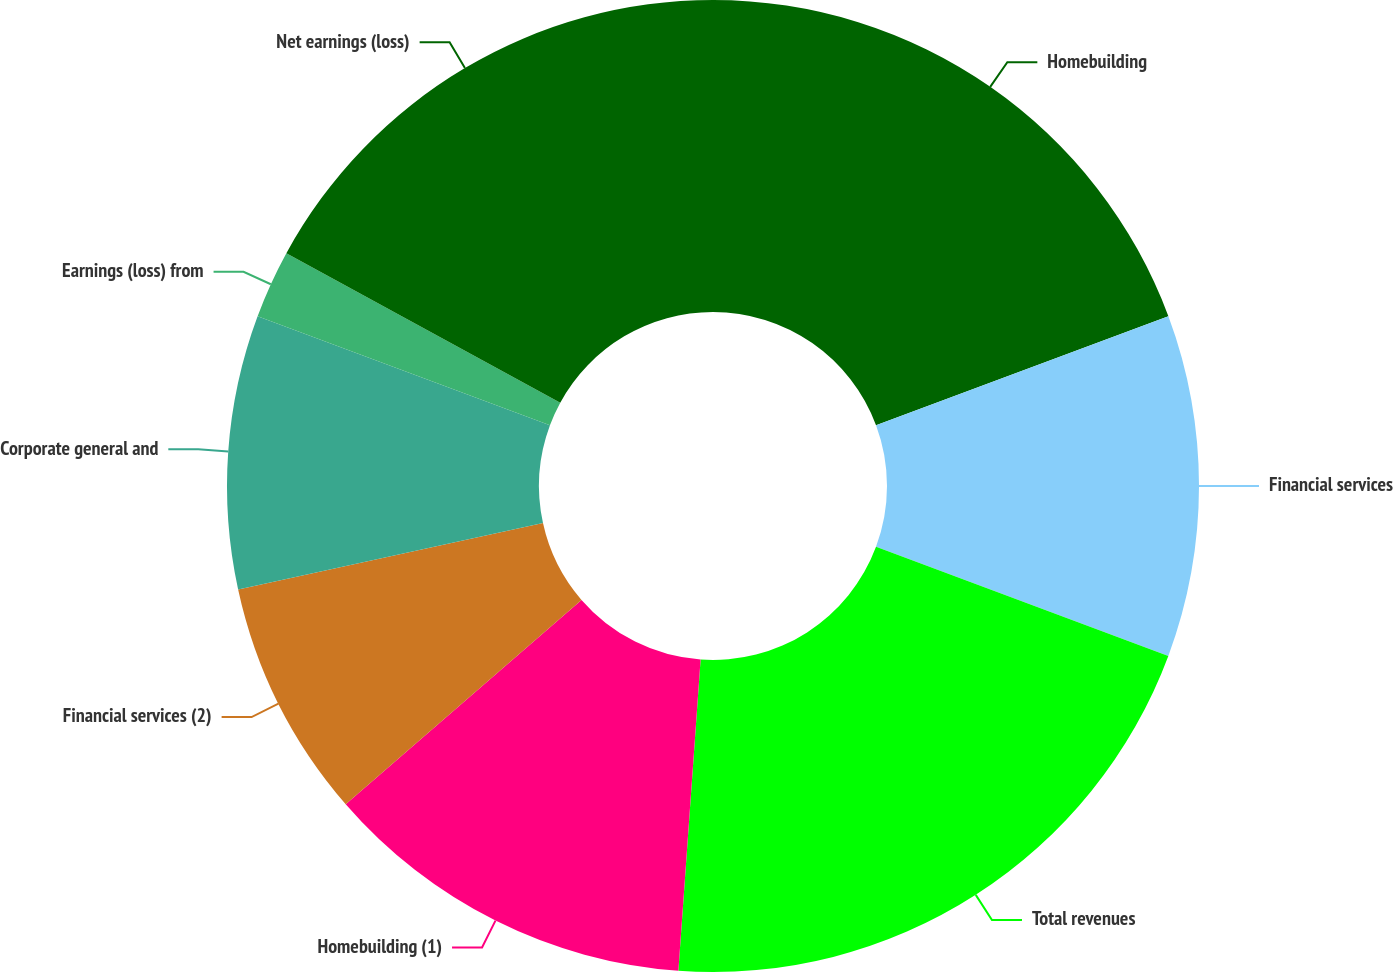Convert chart. <chart><loc_0><loc_0><loc_500><loc_500><pie_chart><fcel>Homebuilding<fcel>Financial services<fcel>Total revenues<fcel>Homebuilding (1)<fcel>Financial services (2)<fcel>Corporate general and<fcel>Earnings (loss) from<fcel>Net earnings (loss)<nl><fcel>19.32%<fcel>11.36%<fcel>20.45%<fcel>12.5%<fcel>7.95%<fcel>9.09%<fcel>2.27%<fcel>17.05%<nl></chart> 